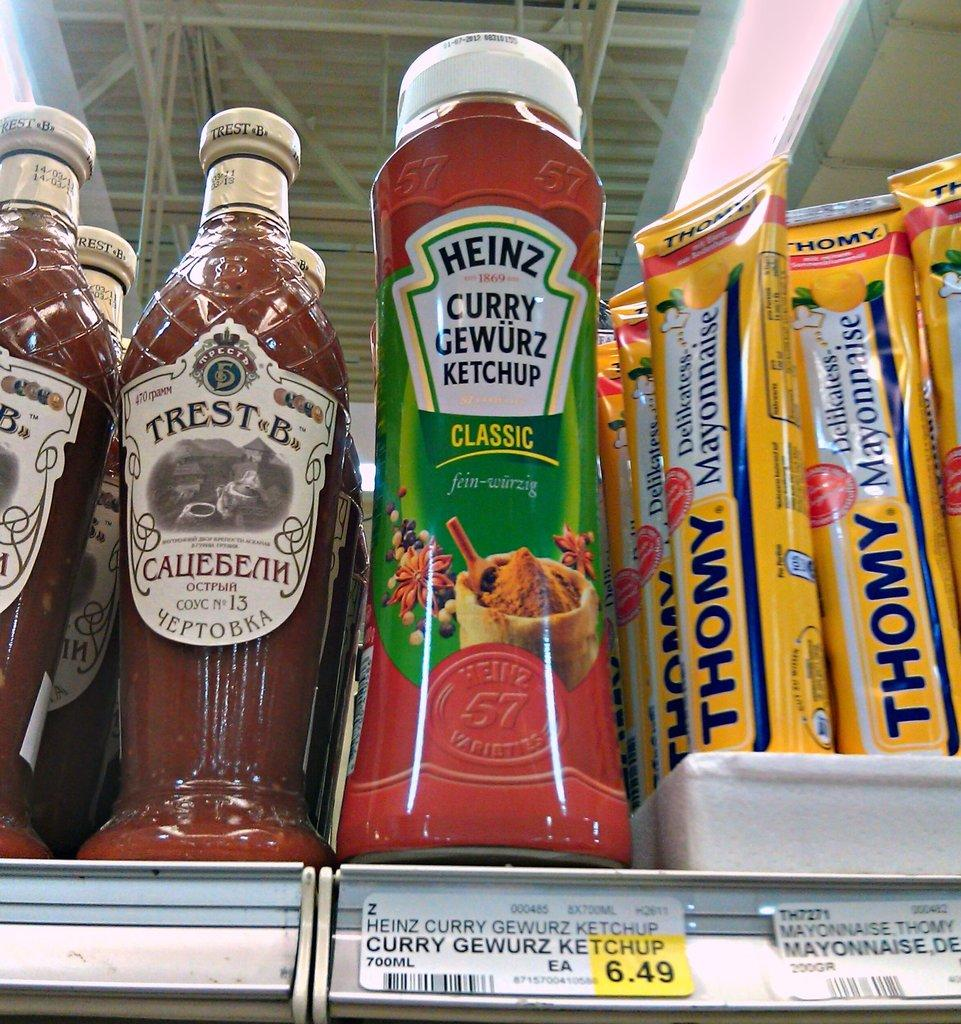<image>
Provide a brief description of the given image. A bottle of ketchup has a price tag of 6.49. 